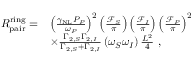<formula> <loc_0><loc_0><loc_500><loc_500>\begin{array} { r l } { R _ { p a i r } ^ { r i n g } = } & { \left ( \frac { \gamma _ { N L } P _ { P } } { \omega _ { P } } \right ) ^ { 2 } \left ( \frac { \mathcal { F } _ { S } } { \pi } \right ) \left ( \frac { \mathcal { F } _ { I } } { \pi } \right ) \left ( \frac { \mathcal { F } _ { P } } { \pi } \right ) ^ { 2 } } \\ & { \times \frac { \Gamma _ { 2 , S } \Gamma _ { 2 , I } } { \Gamma _ { 2 , S } + \Gamma _ { 2 , I } } \left ( \omega _ { S } \omega _ { I } \right ) \frac { L ^ { 2 } } { 4 } \ , } \end{array}</formula> 